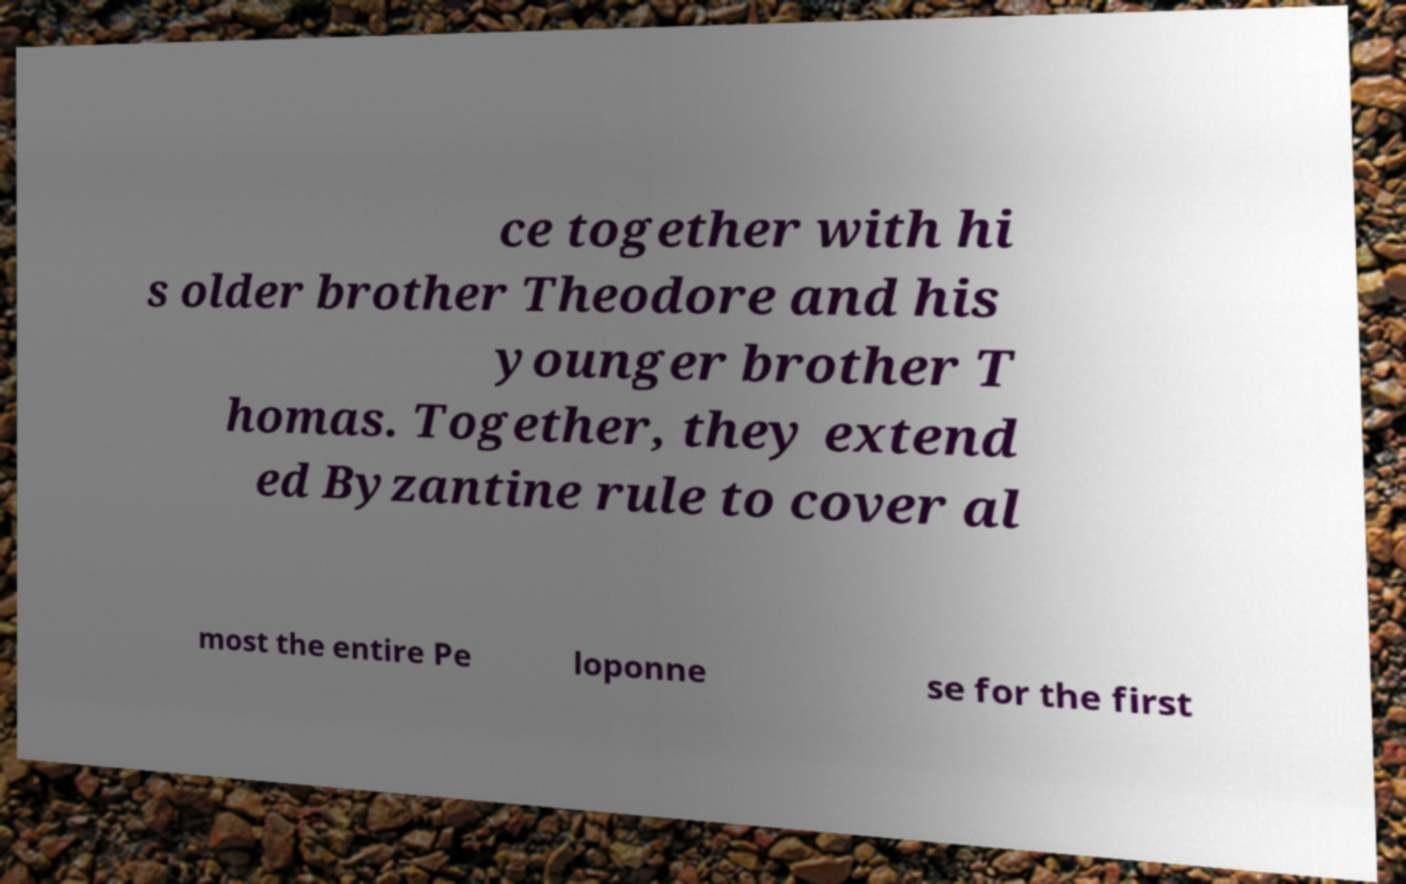I need the written content from this picture converted into text. Can you do that? ce together with hi s older brother Theodore and his younger brother T homas. Together, they extend ed Byzantine rule to cover al most the entire Pe loponne se for the first 